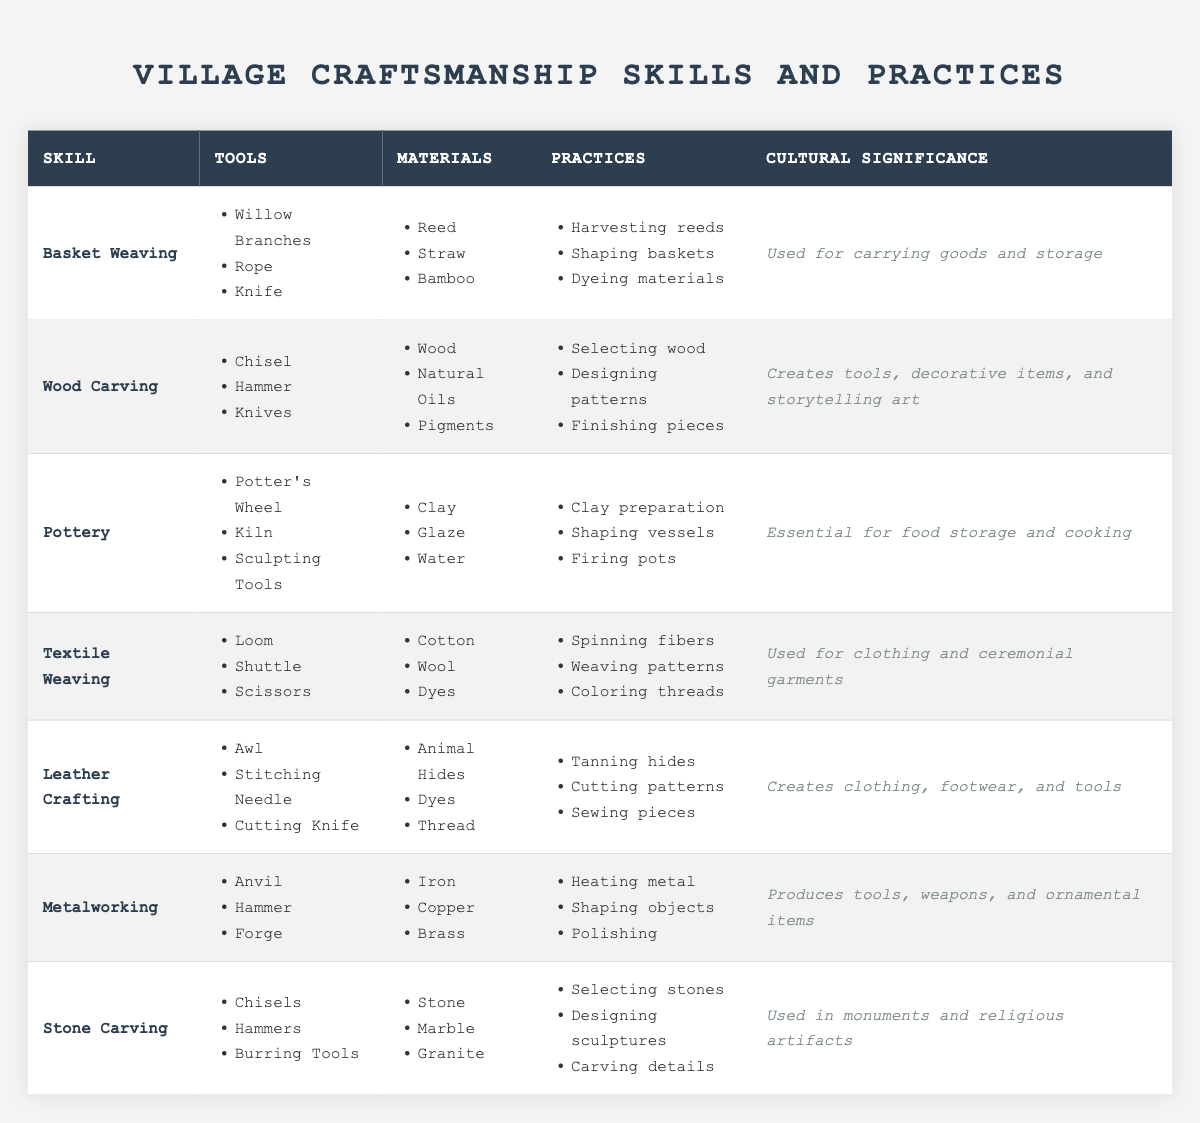What is the cultural significance of Wood Carving? According to the table, the cultural significance of Wood Carving is that it creates tools, decorative items, and storytelling art.
Answer: Creates tools, decorative items, and storytelling art Which tools are used in Textile Weaving? The table lists three tools used in Textile Weaving: Loom, Shuttle, and Scissors.
Answer: Loom, Shuttle, Scissors How many materials are used in Pottery? The table shows that there are three materials used in Pottery: Clay, Glaze, and Water.
Answer: Three Is Basket Weaving significant for food storage? The cultural significance of Basket Weaving is that it is used for carrying goods and storage, but it is not specified as significant for food storage specifically.
Answer: No What are the primary practices involved in Leather Crafting? The table indicates that the primary practices in Leather Crafting include Tanning hides, Cutting patterns, and Sewing pieces.
Answer: Tanning hides, Cutting patterns, Sewing pieces Which craftsmanship skill involves shaping vessels? The table shows that shaping vessels is a practice involved in Pottery.
Answer: Pottery Which two skills use natural materials such as plants or animal hides? The skills that use natural materials are Basket Weaving (which uses plants) and Leather Crafting (which uses animal hides).
Answer: Basket Weaving and Leather Crafting What is the sum of the number of practices listed for all skills? There are 3 practices for Basket Weaving, 3 for Wood Carving, 3 for Pottery, 3 for Textile Weaving, 3 for Leather Crafting, 3 for Metalworking, and 3 for Stone Carving. Therefore, the total is 3 (x7) = 21 practices.
Answer: 21 Which skill has the most tools listed? The table shows that Wood Carving, Pottery, Leather Crafting, and Metalworking each have three tools listed, while the others have fewer. Therefore, they have the most tools listed.
Answer: Wood Carving, Pottery, Leather Crafting, and Metalworking How does the cultural significance of Metalworking compare to that of Stone Carving? Metalworking produces tools, weapons, and ornamental items, while Stone Carving is used in monuments and religious artifacts. Both are significant but serve different functions in culture and utility.
Answer: Both are significant but in different ways 